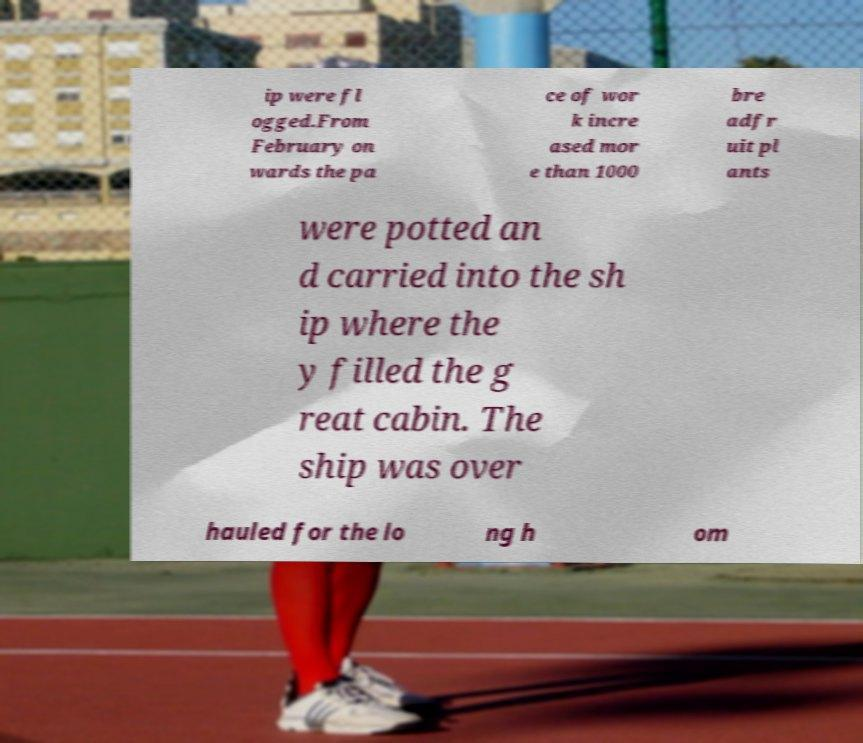Could you assist in decoding the text presented in this image and type it out clearly? ip were fl ogged.From February on wards the pa ce of wor k incre ased mor e than 1000 bre adfr uit pl ants were potted an d carried into the sh ip where the y filled the g reat cabin. The ship was over hauled for the lo ng h om 